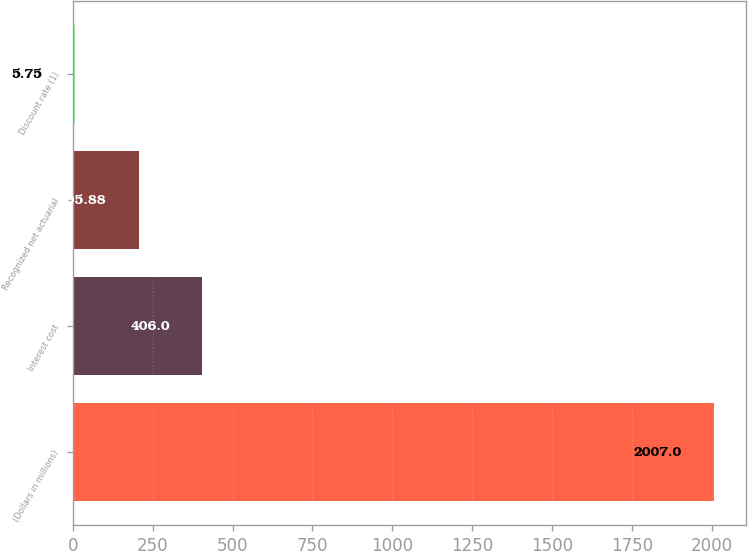<chart> <loc_0><loc_0><loc_500><loc_500><bar_chart><fcel>(Dollars in millions)<fcel>Interest cost<fcel>Recognized net actuarial<fcel>Discount rate (1)<nl><fcel>2007<fcel>406<fcel>205.88<fcel>5.75<nl></chart> 